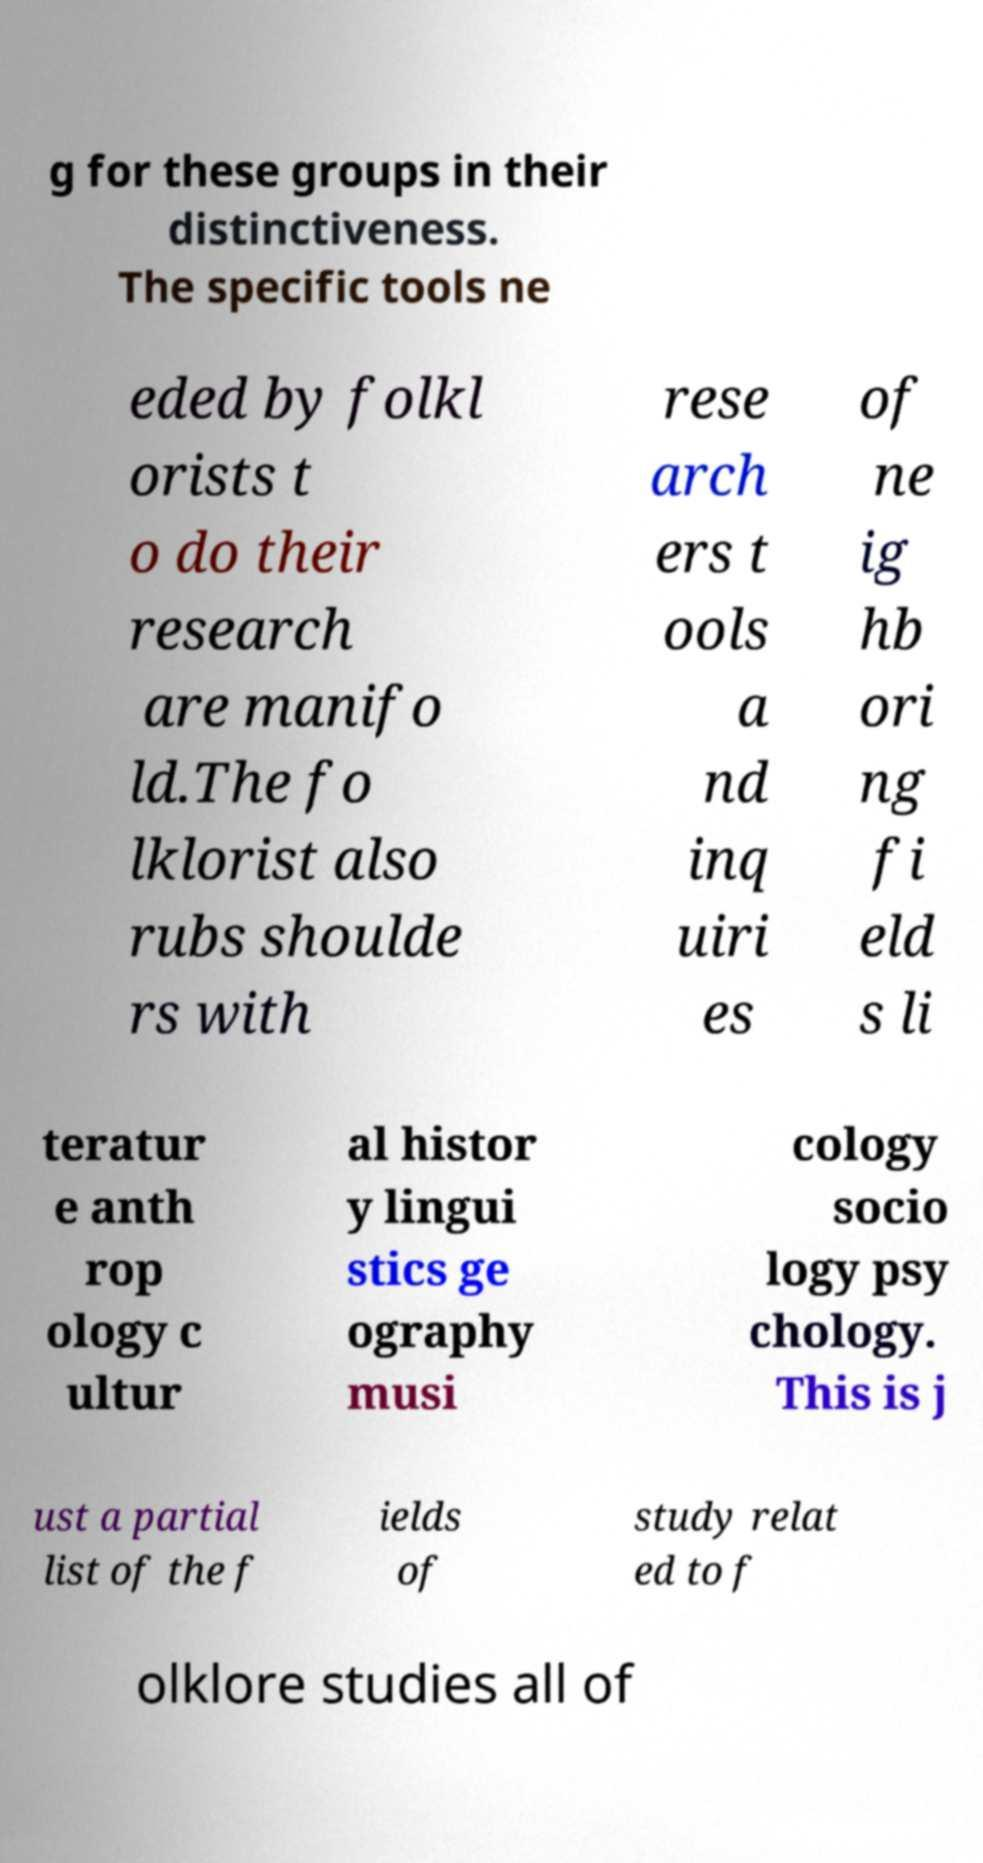Could you assist in decoding the text presented in this image and type it out clearly? g for these groups in their distinctiveness. The specific tools ne eded by folkl orists t o do their research are manifo ld.The fo lklorist also rubs shoulde rs with rese arch ers t ools a nd inq uiri es of ne ig hb ori ng fi eld s li teratur e anth rop ology c ultur al histor y lingui stics ge ography musi cology socio logy psy chology. This is j ust a partial list of the f ields of study relat ed to f olklore studies all of 